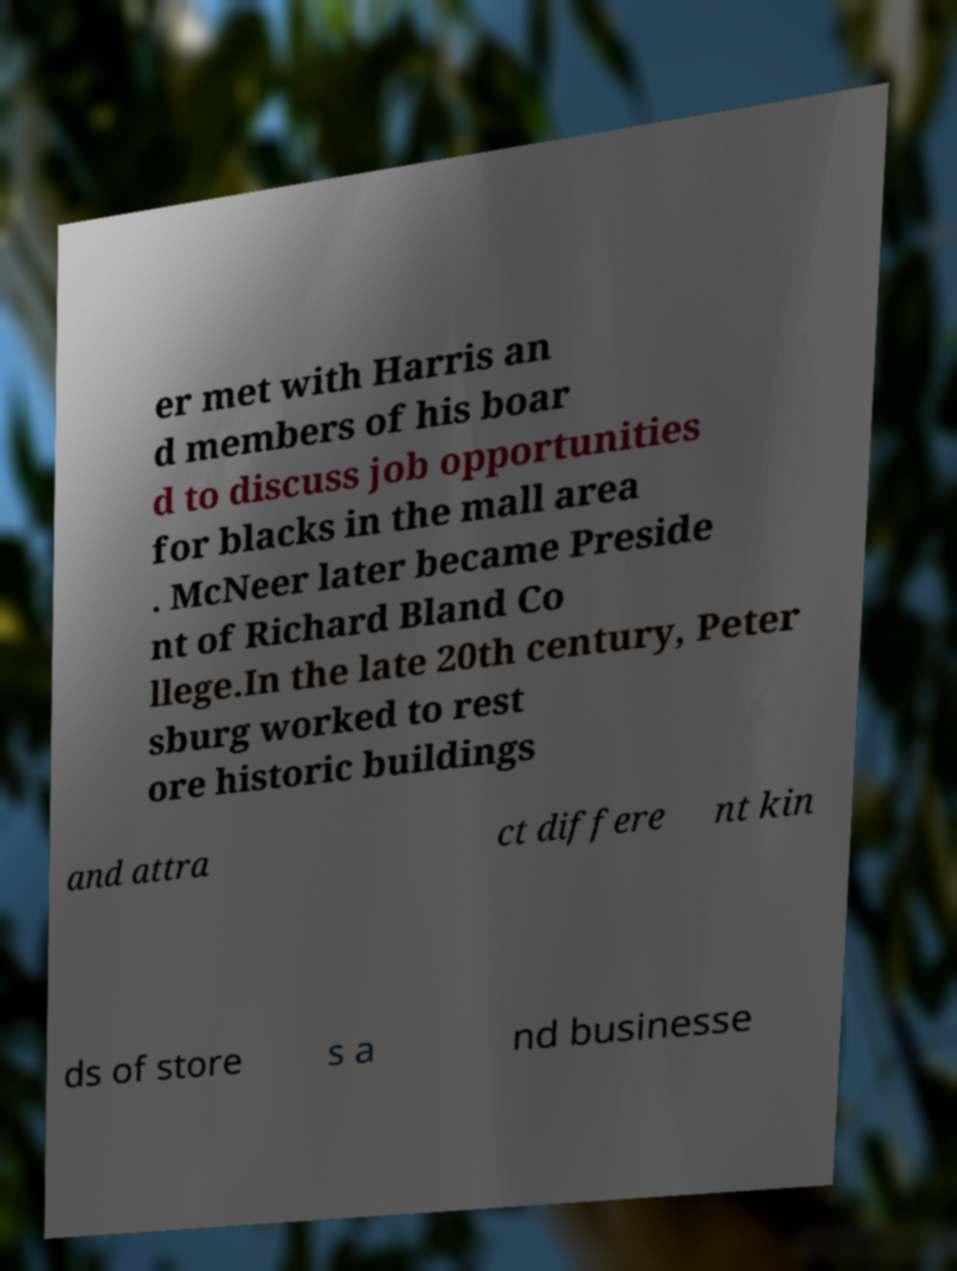Please read and relay the text visible in this image. What does it say? er met with Harris an d members of his boar d to discuss job opportunities for blacks in the mall area . McNeer later became Preside nt of Richard Bland Co llege.In the late 20th century, Peter sburg worked to rest ore historic buildings and attra ct differe nt kin ds of store s a nd businesse 